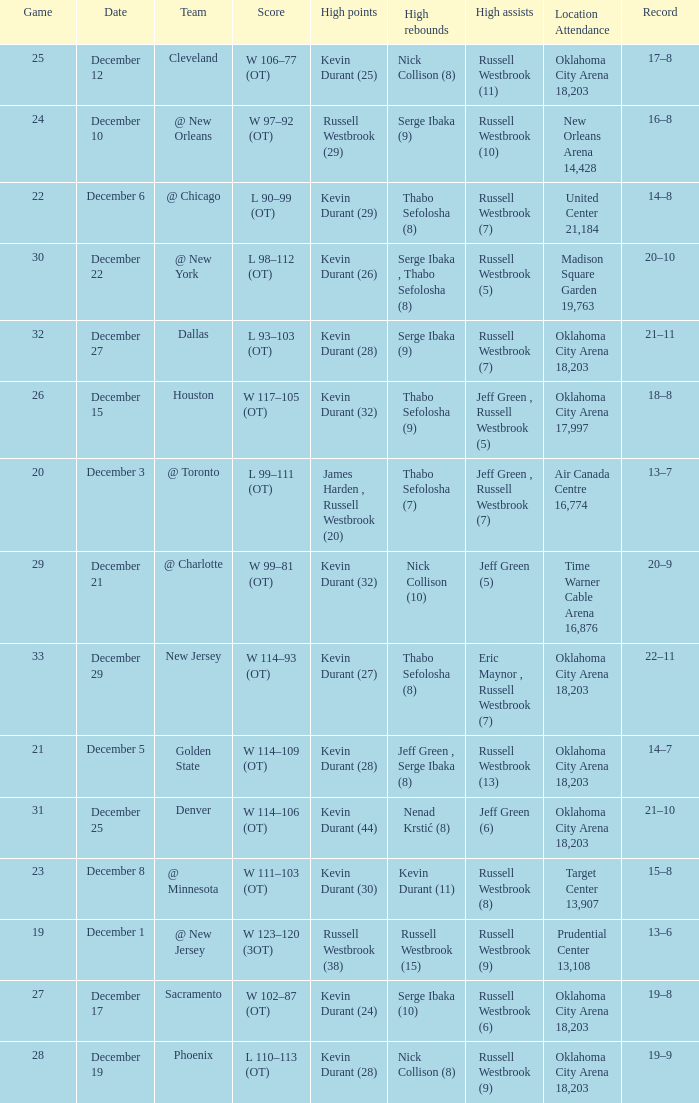What was the record on December 27? 21–11. 